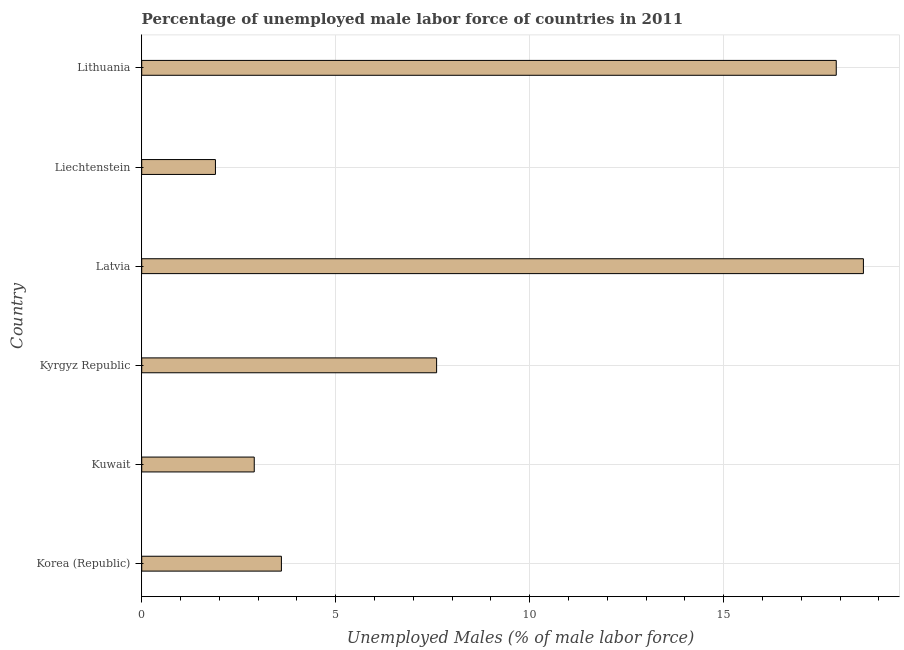What is the title of the graph?
Keep it short and to the point. Percentage of unemployed male labor force of countries in 2011. What is the label or title of the X-axis?
Provide a succinct answer. Unemployed Males (% of male labor force). What is the total unemployed male labour force in Lithuania?
Your answer should be compact. 17.9. Across all countries, what is the maximum total unemployed male labour force?
Give a very brief answer. 18.6. Across all countries, what is the minimum total unemployed male labour force?
Offer a terse response. 1.9. In which country was the total unemployed male labour force maximum?
Provide a short and direct response. Latvia. In which country was the total unemployed male labour force minimum?
Provide a succinct answer. Liechtenstein. What is the sum of the total unemployed male labour force?
Your answer should be compact. 52.5. What is the difference between the total unemployed male labour force in Kyrgyz Republic and Lithuania?
Your answer should be very brief. -10.3. What is the average total unemployed male labour force per country?
Your answer should be compact. 8.75. What is the median total unemployed male labour force?
Give a very brief answer. 5.6. In how many countries, is the total unemployed male labour force greater than 18 %?
Offer a very short reply. 1. What is the ratio of the total unemployed male labour force in Kuwait to that in Kyrgyz Republic?
Your response must be concise. 0.38. Is the total unemployed male labour force in Kyrgyz Republic less than that in Latvia?
Give a very brief answer. Yes. Is the difference between the total unemployed male labour force in Latvia and Liechtenstein greater than the difference between any two countries?
Provide a succinct answer. Yes. What is the difference between the highest and the second highest total unemployed male labour force?
Offer a very short reply. 0.7. In how many countries, is the total unemployed male labour force greater than the average total unemployed male labour force taken over all countries?
Give a very brief answer. 2. Are all the bars in the graph horizontal?
Your response must be concise. Yes. What is the Unemployed Males (% of male labor force) in Korea (Republic)?
Your answer should be compact. 3.6. What is the Unemployed Males (% of male labor force) in Kuwait?
Offer a very short reply. 2.9. What is the Unemployed Males (% of male labor force) in Kyrgyz Republic?
Your answer should be compact. 7.6. What is the Unemployed Males (% of male labor force) in Latvia?
Give a very brief answer. 18.6. What is the Unemployed Males (% of male labor force) in Liechtenstein?
Offer a terse response. 1.9. What is the Unemployed Males (% of male labor force) of Lithuania?
Offer a very short reply. 17.9. What is the difference between the Unemployed Males (% of male labor force) in Korea (Republic) and Latvia?
Provide a short and direct response. -15. What is the difference between the Unemployed Males (% of male labor force) in Korea (Republic) and Liechtenstein?
Offer a very short reply. 1.7. What is the difference between the Unemployed Males (% of male labor force) in Korea (Republic) and Lithuania?
Keep it short and to the point. -14.3. What is the difference between the Unemployed Males (% of male labor force) in Kuwait and Kyrgyz Republic?
Offer a very short reply. -4.7. What is the difference between the Unemployed Males (% of male labor force) in Kuwait and Latvia?
Give a very brief answer. -15.7. What is the difference between the Unemployed Males (% of male labor force) in Kuwait and Liechtenstein?
Make the answer very short. 1. What is the difference between the Unemployed Males (% of male labor force) in Kuwait and Lithuania?
Make the answer very short. -15. What is the difference between the Unemployed Males (% of male labor force) in Kyrgyz Republic and Lithuania?
Ensure brevity in your answer.  -10.3. What is the difference between the Unemployed Males (% of male labor force) in Latvia and Lithuania?
Offer a terse response. 0.7. What is the difference between the Unemployed Males (% of male labor force) in Liechtenstein and Lithuania?
Your answer should be very brief. -16. What is the ratio of the Unemployed Males (% of male labor force) in Korea (Republic) to that in Kuwait?
Offer a very short reply. 1.24. What is the ratio of the Unemployed Males (% of male labor force) in Korea (Republic) to that in Kyrgyz Republic?
Your answer should be compact. 0.47. What is the ratio of the Unemployed Males (% of male labor force) in Korea (Republic) to that in Latvia?
Keep it short and to the point. 0.19. What is the ratio of the Unemployed Males (% of male labor force) in Korea (Republic) to that in Liechtenstein?
Ensure brevity in your answer.  1.9. What is the ratio of the Unemployed Males (% of male labor force) in Korea (Republic) to that in Lithuania?
Offer a very short reply. 0.2. What is the ratio of the Unemployed Males (% of male labor force) in Kuwait to that in Kyrgyz Republic?
Offer a very short reply. 0.38. What is the ratio of the Unemployed Males (% of male labor force) in Kuwait to that in Latvia?
Offer a very short reply. 0.16. What is the ratio of the Unemployed Males (% of male labor force) in Kuwait to that in Liechtenstein?
Offer a very short reply. 1.53. What is the ratio of the Unemployed Males (% of male labor force) in Kuwait to that in Lithuania?
Your answer should be compact. 0.16. What is the ratio of the Unemployed Males (% of male labor force) in Kyrgyz Republic to that in Latvia?
Provide a short and direct response. 0.41. What is the ratio of the Unemployed Males (% of male labor force) in Kyrgyz Republic to that in Liechtenstein?
Provide a short and direct response. 4. What is the ratio of the Unemployed Males (% of male labor force) in Kyrgyz Republic to that in Lithuania?
Your response must be concise. 0.42. What is the ratio of the Unemployed Males (% of male labor force) in Latvia to that in Liechtenstein?
Ensure brevity in your answer.  9.79. What is the ratio of the Unemployed Males (% of male labor force) in Latvia to that in Lithuania?
Your answer should be compact. 1.04. What is the ratio of the Unemployed Males (% of male labor force) in Liechtenstein to that in Lithuania?
Provide a short and direct response. 0.11. 